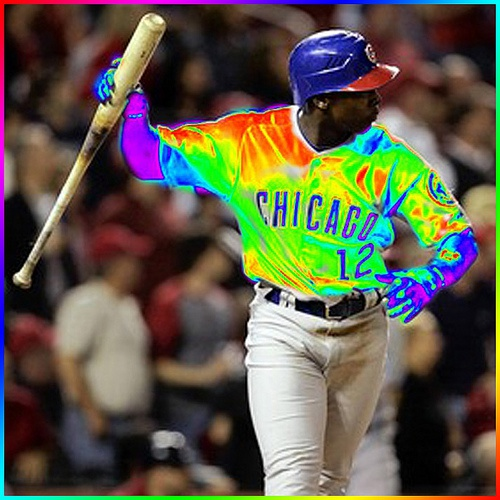Describe the objects in this image and their specific colors. I can see people in red, lightgray, yellow, black, and lime tones, people in red, darkgray, maroon, gray, and black tones, people in red, black, gray, and maroon tones, baseball bat in red, tan, khaki, beige, and black tones, and people in red, gray, maroon, and black tones in this image. 